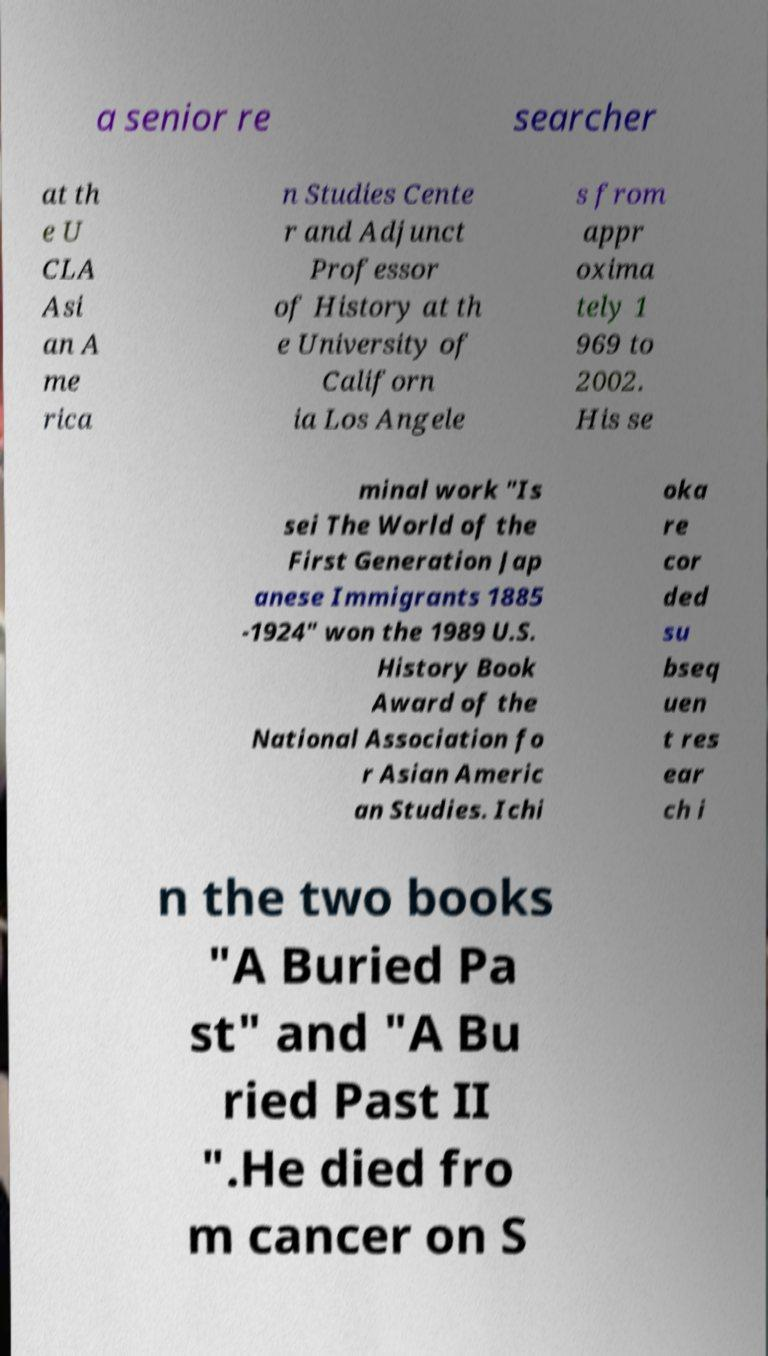Can you accurately transcribe the text from the provided image for me? a senior re searcher at th e U CLA Asi an A me rica n Studies Cente r and Adjunct Professor of History at th e University of Californ ia Los Angele s from appr oxima tely 1 969 to 2002. His se minal work "Is sei The World of the First Generation Jap anese Immigrants 1885 -1924" won the 1989 U.S. History Book Award of the National Association fo r Asian Americ an Studies. Ichi oka re cor ded su bseq uen t res ear ch i n the two books "A Buried Pa st" and "A Bu ried Past II ".He died fro m cancer on S 